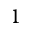<formula> <loc_0><loc_0><loc_500><loc_500>1</formula> 